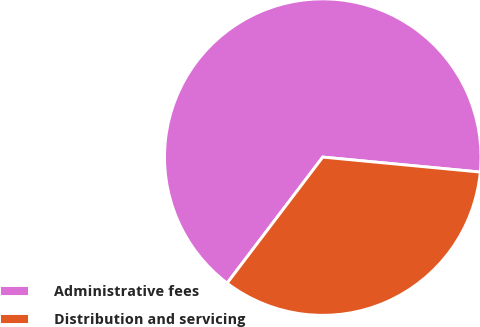Convert chart to OTSL. <chart><loc_0><loc_0><loc_500><loc_500><pie_chart><fcel>Administrative fees<fcel>Distribution and servicing<nl><fcel>66.18%<fcel>33.82%<nl></chart> 